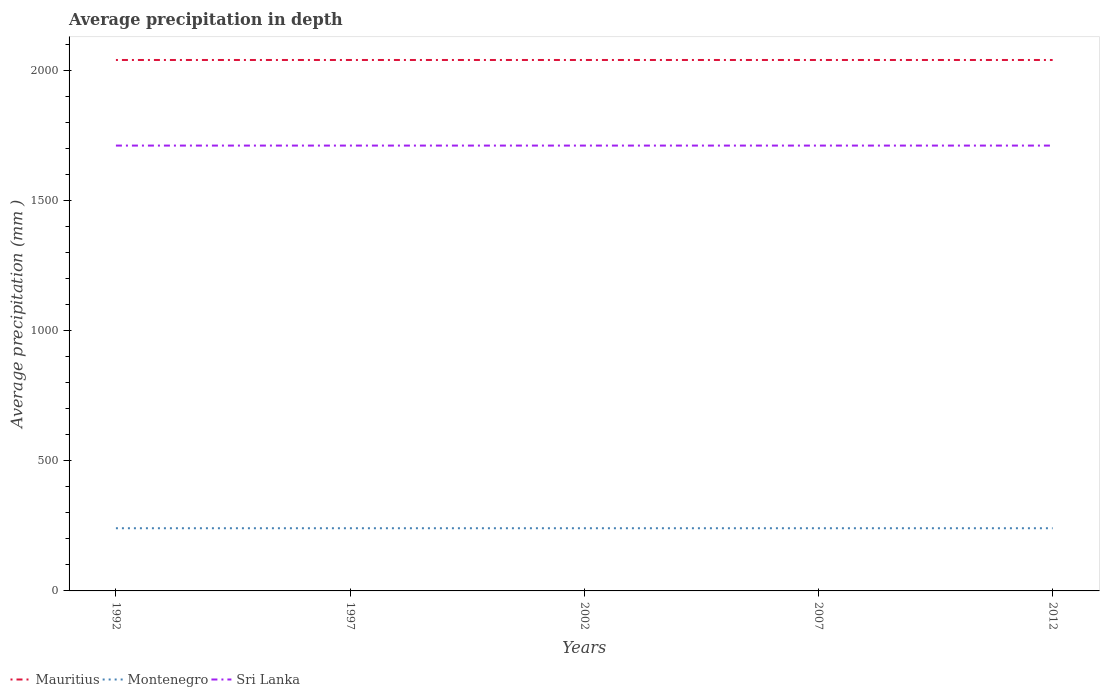Does the line corresponding to Sri Lanka intersect with the line corresponding to Mauritius?
Your response must be concise. No. Across all years, what is the maximum average precipitation in Sri Lanka?
Your response must be concise. 1712. In which year was the average precipitation in Sri Lanka maximum?
Make the answer very short. 1992. What is the total average precipitation in Montenegro in the graph?
Give a very brief answer. 0. What is the difference between the highest and the second highest average precipitation in Mauritius?
Ensure brevity in your answer.  0. What is the difference between the highest and the lowest average precipitation in Montenegro?
Your answer should be very brief. 0. How many lines are there?
Make the answer very short. 3. What is the difference between two consecutive major ticks on the Y-axis?
Your answer should be very brief. 500. Does the graph contain any zero values?
Offer a very short reply. No. What is the title of the graph?
Make the answer very short. Average precipitation in depth. Does "Ireland" appear as one of the legend labels in the graph?
Your answer should be compact. No. What is the label or title of the X-axis?
Offer a very short reply. Years. What is the label or title of the Y-axis?
Your answer should be compact. Average precipitation (mm ). What is the Average precipitation (mm ) of Mauritius in 1992?
Make the answer very short. 2041. What is the Average precipitation (mm ) of Montenegro in 1992?
Provide a short and direct response. 241. What is the Average precipitation (mm ) in Sri Lanka in 1992?
Your answer should be very brief. 1712. What is the Average precipitation (mm ) of Mauritius in 1997?
Offer a very short reply. 2041. What is the Average precipitation (mm ) in Montenegro in 1997?
Your response must be concise. 241. What is the Average precipitation (mm ) in Sri Lanka in 1997?
Your answer should be very brief. 1712. What is the Average precipitation (mm ) in Mauritius in 2002?
Provide a short and direct response. 2041. What is the Average precipitation (mm ) in Montenegro in 2002?
Your response must be concise. 241. What is the Average precipitation (mm ) of Sri Lanka in 2002?
Provide a short and direct response. 1712. What is the Average precipitation (mm ) in Mauritius in 2007?
Provide a succinct answer. 2041. What is the Average precipitation (mm ) of Montenegro in 2007?
Your answer should be very brief. 241. What is the Average precipitation (mm ) in Sri Lanka in 2007?
Provide a succinct answer. 1712. What is the Average precipitation (mm ) in Mauritius in 2012?
Your answer should be compact. 2041. What is the Average precipitation (mm ) of Montenegro in 2012?
Offer a very short reply. 241. What is the Average precipitation (mm ) of Sri Lanka in 2012?
Make the answer very short. 1712. Across all years, what is the maximum Average precipitation (mm ) of Mauritius?
Make the answer very short. 2041. Across all years, what is the maximum Average precipitation (mm ) of Montenegro?
Keep it short and to the point. 241. Across all years, what is the maximum Average precipitation (mm ) in Sri Lanka?
Your answer should be very brief. 1712. Across all years, what is the minimum Average precipitation (mm ) in Mauritius?
Offer a very short reply. 2041. Across all years, what is the minimum Average precipitation (mm ) of Montenegro?
Ensure brevity in your answer.  241. Across all years, what is the minimum Average precipitation (mm ) of Sri Lanka?
Provide a short and direct response. 1712. What is the total Average precipitation (mm ) of Mauritius in the graph?
Your response must be concise. 1.02e+04. What is the total Average precipitation (mm ) in Montenegro in the graph?
Offer a very short reply. 1205. What is the total Average precipitation (mm ) of Sri Lanka in the graph?
Make the answer very short. 8560. What is the difference between the Average precipitation (mm ) in Mauritius in 1992 and that in 1997?
Keep it short and to the point. 0. What is the difference between the Average precipitation (mm ) of Montenegro in 1992 and that in 1997?
Your answer should be very brief. 0. What is the difference between the Average precipitation (mm ) in Mauritius in 1992 and that in 2002?
Your answer should be very brief. 0. What is the difference between the Average precipitation (mm ) in Sri Lanka in 1992 and that in 2002?
Your answer should be very brief. 0. What is the difference between the Average precipitation (mm ) of Montenegro in 1992 and that in 2012?
Give a very brief answer. 0. What is the difference between the Average precipitation (mm ) of Sri Lanka in 1992 and that in 2012?
Give a very brief answer. 0. What is the difference between the Average precipitation (mm ) of Sri Lanka in 1997 and that in 2002?
Make the answer very short. 0. What is the difference between the Average precipitation (mm ) in Mauritius in 1997 and that in 2012?
Your answer should be very brief. 0. What is the difference between the Average precipitation (mm ) of Montenegro in 1997 and that in 2012?
Provide a short and direct response. 0. What is the difference between the Average precipitation (mm ) of Mauritius in 2002 and that in 2007?
Your response must be concise. 0. What is the difference between the Average precipitation (mm ) of Montenegro in 2007 and that in 2012?
Keep it short and to the point. 0. What is the difference between the Average precipitation (mm ) in Mauritius in 1992 and the Average precipitation (mm ) in Montenegro in 1997?
Make the answer very short. 1800. What is the difference between the Average precipitation (mm ) of Mauritius in 1992 and the Average precipitation (mm ) of Sri Lanka in 1997?
Your response must be concise. 329. What is the difference between the Average precipitation (mm ) in Montenegro in 1992 and the Average precipitation (mm ) in Sri Lanka in 1997?
Your answer should be very brief. -1471. What is the difference between the Average precipitation (mm ) in Mauritius in 1992 and the Average precipitation (mm ) in Montenegro in 2002?
Ensure brevity in your answer.  1800. What is the difference between the Average precipitation (mm ) of Mauritius in 1992 and the Average precipitation (mm ) of Sri Lanka in 2002?
Provide a short and direct response. 329. What is the difference between the Average precipitation (mm ) of Montenegro in 1992 and the Average precipitation (mm ) of Sri Lanka in 2002?
Provide a short and direct response. -1471. What is the difference between the Average precipitation (mm ) in Mauritius in 1992 and the Average precipitation (mm ) in Montenegro in 2007?
Give a very brief answer. 1800. What is the difference between the Average precipitation (mm ) of Mauritius in 1992 and the Average precipitation (mm ) of Sri Lanka in 2007?
Provide a succinct answer. 329. What is the difference between the Average precipitation (mm ) of Montenegro in 1992 and the Average precipitation (mm ) of Sri Lanka in 2007?
Keep it short and to the point. -1471. What is the difference between the Average precipitation (mm ) of Mauritius in 1992 and the Average precipitation (mm ) of Montenegro in 2012?
Your answer should be very brief. 1800. What is the difference between the Average precipitation (mm ) of Mauritius in 1992 and the Average precipitation (mm ) of Sri Lanka in 2012?
Provide a short and direct response. 329. What is the difference between the Average precipitation (mm ) in Montenegro in 1992 and the Average precipitation (mm ) in Sri Lanka in 2012?
Your answer should be very brief. -1471. What is the difference between the Average precipitation (mm ) of Mauritius in 1997 and the Average precipitation (mm ) of Montenegro in 2002?
Keep it short and to the point. 1800. What is the difference between the Average precipitation (mm ) of Mauritius in 1997 and the Average precipitation (mm ) of Sri Lanka in 2002?
Offer a very short reply. 329. What is the difference between the Average precipitation (mm ) of Montenegro in 1997 and the Average precipitation (mm ) of Sri Lanka in 2002?
Provide a short and direct response. -1471. What is the difference between the Average precipitation (mm ) of Mauritius in 1997 and the Average precipitation (mm ) of Montenegro in 2007?
Make the answer very short. 1800. What is the difference between the Average precipitation (mm ) of Mauritius in 1997 and the Average precipitation (mm ) of Sri Lanka in 2007?
Give a very brief answer. 329. What is the difference between the Average precipitation (mm ) of Montenegro in 1997 and the Average precipitation (mm ) of Sri Lanka in 2007?
Give a very brief answer. -1471. What is the difference between the Average precipitation (mm ) of Mauritius in 1997 and the Average precipitation (mm ) of Montenegro in 2012?
Provide a short and direct response. 1800. What is the difference between the Average precipitation (mm ) of Mauritius in 1997 and the Average precipitation (mm ) of Sri Lanka in 2012?
Keep it short and to the point. 329. What is the difference between the Average precipitation (mm ) in Montenegro in 1997 and the Average precipitation (mm ) in Sri Lanka in 2012?
Your answer should be very brief. -1471. What is the difference between the Average precipitation (mm ) of Mauritius in 2002 and the Average precipitation (mm ) of Montenegro in 2007?
Make the answer very short. 1800. What is the difference between the Average precipitation (mm ) in Mauritius in 2002 and the Average precipitation (mm ) in Sri Lanka in 2007?
Your response must be concise. 329. What is the difference between the Average precipitation (mm ) of Montenegro in 2002 and the Average precipitation (mm ) of Sri Lanka in 2007?
Give a very brief answer. -1471. What is the difference between the Average precipitation (mm ) of Mauritius in 2002 and the Average precipitation (mm ) of Montenegro in 2012?
Your answer should be compact. 1800. What is the difference between the Average precipitation (mm ) of Mauritius in 2002 and the Average precipitation (mm ) of Sri Lanka in 2012?
Ensure brevity in your answer.  329. What is the difference between the Average precipitation (mm ) in Montenegro in 2002 and the Average precipitation (mm ) in Sri Lanka in 2012?
Offer a very short reply. -1471. What is the difference between the Average precipitation (mm ) of Mauritius in 2007 and the Average precipitation (mm ) of Montenegro in 2012?
Ensure brevity in your answer.  1800. What is the difference between the Average precipitation (mm ) of Mauritius in 2007 and the Average precipitation (mm ) of Sri Lanka in 2012?
Provide a succinct answer. 329. What is the difference between the Average precipitation (mm ) of Montenegro in 2007 and the Average precipitation (mm ) of Sri Lanka in 2012?
Give a very brief answer. -1471. What is the average Average precipitation (mm ) of Mauritius per year?
Keep it short and to the point. 2041. What is the average Average precipitation (mm ) in Montenegro per year?
Make the answer very short. 241. What is the average Average precipitation (mm ) of Sri Lanka per year?
Ensure brevity in your answer.  1712. In the year 1992, what is the difference between the Average precipitation (mm ) in Mauritius and Average precipitation (mm ) in Montenegro?
Keep it short and to the point. 1800. In the year 1992, what is the difference between the Average precipitation (mm ) in Mauritius and Average precipitation (mm ) in Sri Lanka?
Your answer should be compact. 329. In the year 1992, what is the difference between the Average precipitation (mm ) in Montenegro and Average precipitation (mm ) in Sri Lanka?
Your answer should be very brief. -1471. In the year 1997, what is the difference between the Average precipitation (mm ) in Mauritius and Average precipitation (mm ) in Montenegro?
Provide a succinct answer. 1800. In the year 1997, what is the difference between the Average precipitation (mm ) of Mauritius and Average precipitation (mm ) of Sri Lanka?
Give a very brief answer. 329. In the year 1997, what is the difference between the Average precipitation (mm ) of Montenegro and Average precipitation (mm ) of Sri Lanka?
Your response must be concise. -1471. In the year 2002, what is the difference between the Average precipitation (mm ) in Mauritius and Average precipitation (mm ) in Montenegro?
Give a very brief answer. 1800. In the year 2002, what is the difference between the Average precipitation (mm ) in Mauritius and Average precipitation (mm ) in Sri Lanka?
Offer a terse response. 329. In the year 2002, what is the difference between the Average precipitation (mm ) of Montenegro and Average precipitation (mm ) of Sri Lanka?
Your answer should be compact. -1471. In the year 2007, what is the difference between the Average precipitation (mm ) in Mauritius and Average precipitation (mm ) in Montenegro?
Provide a succinct answer. 1800. In the year 2007, what is the difference between the Average precipitation (mm ) in Mauritius and Average precipitation (mm ) in Sri Lanka?
Your response must be concise. 329. In the year 2007, what is the difference between the Average precipitation (mm ) of Montenegro and Average precipitation (mm ) of Sri Lanka?
Offer a very short reply. -1471. In the year 2012, what is the difference between the Average precipitation (mm ) of Mauritius and Average precipitation (mm ) of Montenegro?
Your response must be concise. 1800. In the year 2012, what is the difference between the Average precipitation (mm ) in Mauritius and Average precipitation (mm ) in Sri Lanka?
Offer a terse response. 329. In the year 2012, what is the difference between the Average precipitation (mm ) in Montenegro and Average precipitation (mm ) in Sri Lanka?
Ensure brevity in your answer.  -1471. What is the ratio of the Average precipitation (mm ) of Montenegro in 1992 to that in 1997?
Ensure brevity in your answer.  1. What is the ratio of the Average precipitation (mm ) of Sri Lanka in 1992 to that in 1997?
Make the answer very short. 1. What is the ratio of the Average precipitation (mm ) of Montenegro in 1992 to that in 2007?
Your response must be concise. 1. What is the ratio of the Average precipitation (mm ) in Mauritius in 1992 to that in 2012?
Your response must be concise. 1. What is the ratio of the Average precipitation (mm ) of Sri Lanka in 1992 to that in 2012?
Give a very brief answer. 1. What is the ratio of the Average precipitation (mm ) in Mauritius in 1997 to that in 2002?
Your answer should be very brief. 1. What is the ratio of the Average precipitation (mm ) in Mauritius in 1997 to that in 2012?
Your response must be concise. 1. What is the ratio of the Average precipitation (mm ) of Montenegro in 1997 to that in 2012?
Your answer should be compact. 1. What is the ratio of the Average precipitation (mm ) in Sri Lanka in 1997 to that in 2012?
Your answer should be compact. 1. What is the ratio of the Average precipitation (mm ) in Mauritius in 2002 to that in 2007?
Offer a very short reply. 1. What is the ratio of the Average precipitation (mm ) in Mauritius in 2002 to that in 2012?
Offer a terse response. 1. What is the ratio of the Average precipitation (mm ) of Mauritius in 2007 to that in 2012?
Make the answer very short. 1. What is the ratio of the Average precipitation (mm ) in Montenegro in 2007 to that in 2012?
Give a very brief answer. 1. What is the ratio of the Average precipitation (mm ) in Sri Lanka in 2007 to that in 2012?
Offer a very short reply. 1. What is the difference between the highest and the second highest Average precipitation (mm ) of Mauritius?
Provide a succinct answer. 0. What is the difference between the highest and the second highest Average precipitation (mm ) of Montenegro?
Offer a very short reply. 0. What is the difference between the highest and the second highest Average precipitation (mm ) in Sri Lanka?
Provide a short and direct response. 0. What is the difference between the highest and the lowest Average precipitation (mm ) of Sri Lanka?
Offer a very short reply. 0. 